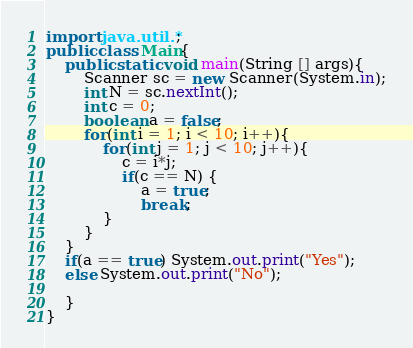Convert code to text. <code><loc_0><loc_0><loc_500><loc_500><_Java_>import java.util.*;
public class Main{
    public static void main(String [] args){
        Scanner sc = new Scanner(System.in);
        int N = sc.nextInt();
        int c = 0;
        boolean a = false;
        for(int i = 1; i < 10; i++){
            for(int j = 1; j < 10; j++){
                c = i*j;
                if(c == N) {
                    a = true;
                    break;
            }
        }
    }
    if(a == true) System.out.print("Yes");
    else System.out.print("No");

    }
}</code> 